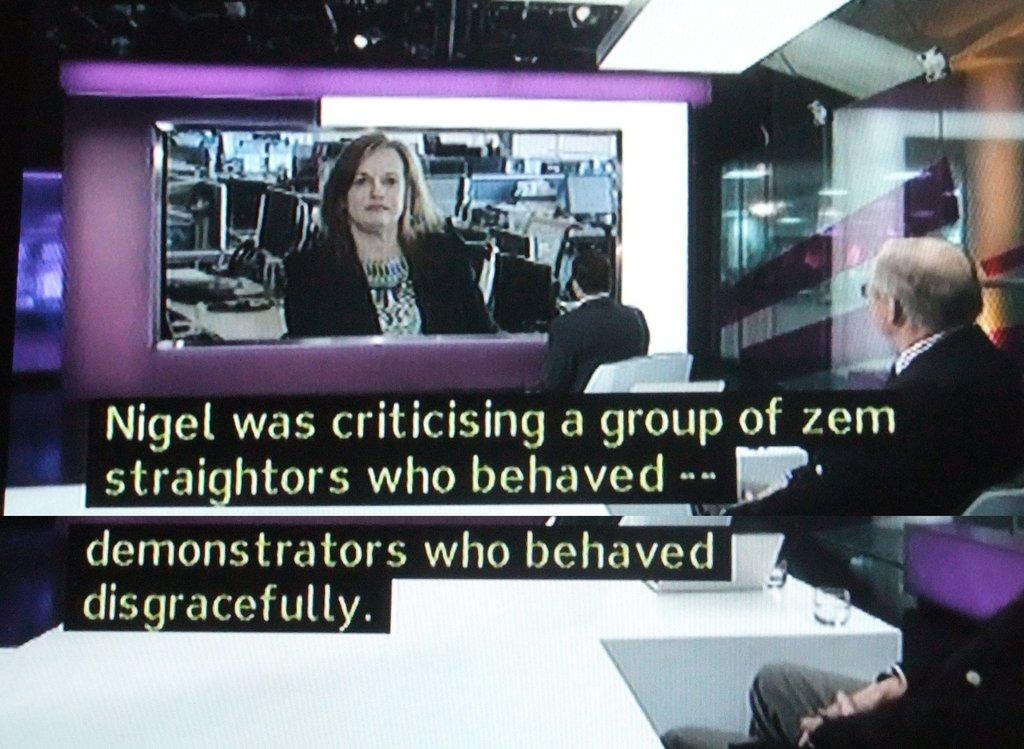Who is criticizing a group of zem straightors?
Your response must be concise. Nigel. How did the demonstrators behave?
Make the answer very short. Disgracefully. 